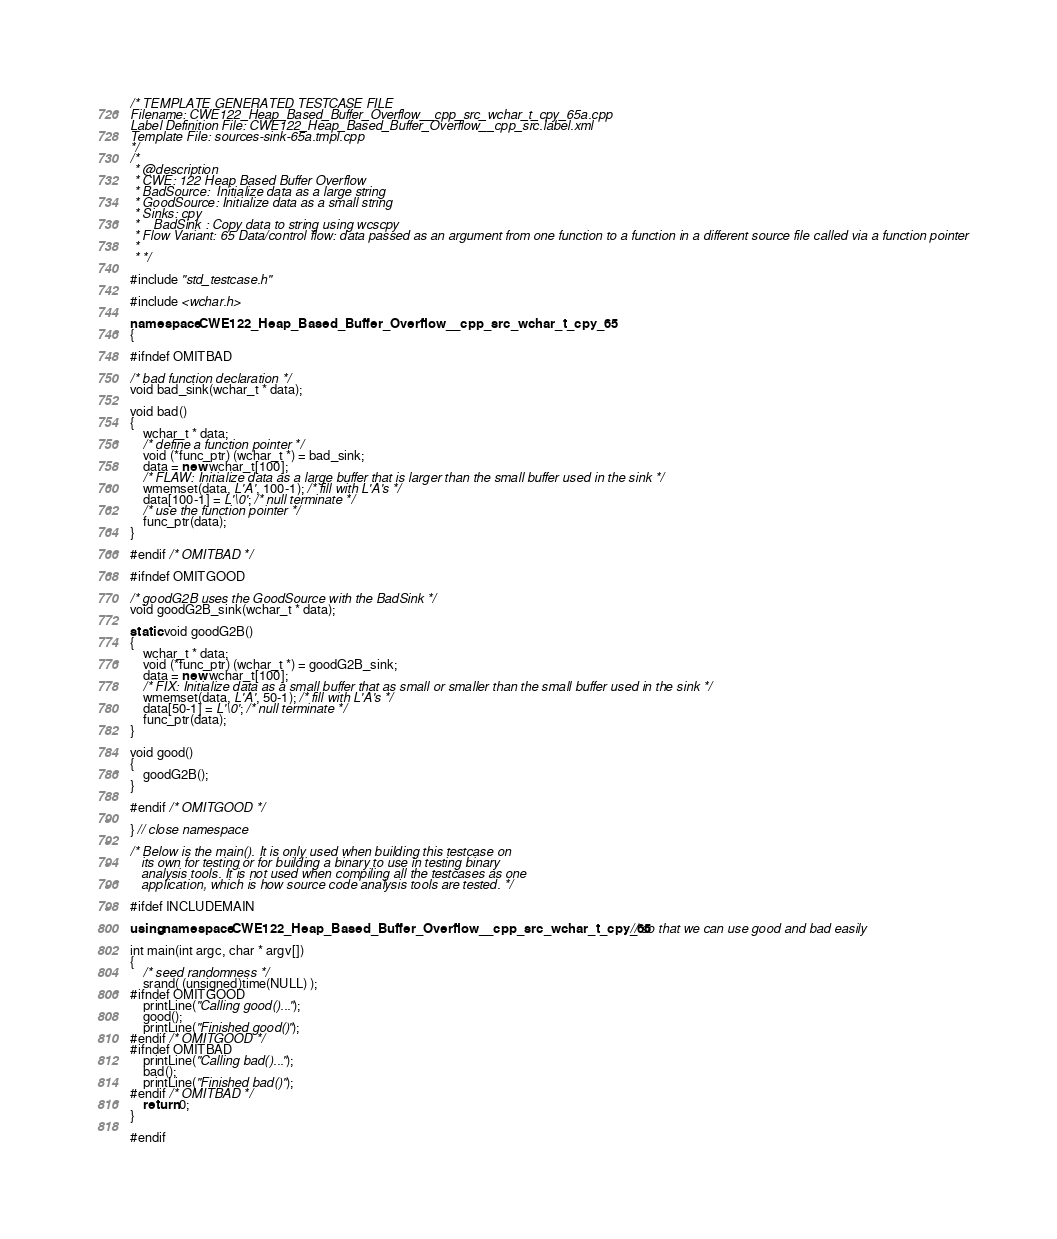Convert code to text. <code><loc_0><loc_0><loc_500><loc_500><_C++_>/* TEMPLATE GENERATED TESTCASE FILE
Filename: CWE122_Heap_Based_Buffer_Overflow__cpp_src_wchar_t_cpy_65a.cpp
Label Definition File: CWE122_Heap_Based_Buffer_Overflow__cpp_src.label.xml
Template File: sources-sink-65a.tmpl.cpp
*/
/*
 * @description
 * CWE: 122 Heap Based Buffer Overflow
 * BadSource:  Initialize data as a large string
 * GoodSource: Initialize data as a small string
 * Sinks: cpy
 *    BadSink : Copy data to string using wcscpy
 * Flow Variant: 65 Data/control flow: data passed as an argument from one function to a function in a different source file called via a function pointer
 *
 * */

#include "std_testcase.h"

#include <wchar.h>

namespace CWE122_Heap_Based_Buffer_Overflow__cpp_src_wchar_t_cpy_65
{

#ifndef OMITBAD

/* bad function declaration */
void bad_sink(wchar_t * data);

void bad()
{
    wchar_t * data;
    /* define a function pointer */
    void (*func_ptr) (wchar_t *) = bad_sink;
    data = new wchar_t[100];
    /* FLAW: Initialize data as a large buffer that is larger than the small buffer used in the sink */
    wmemset(data, L'A', 100-1); /* fill with L'A's */
    data[100-1] = L'\0'; /* null terminate */
    /* use the function pointer */
    func_ptr(data);
}

#endif /* OMITBAD */

#ifndef OMITGOOD

/* goodG2B uses the GoodSource with the BadSink */
void goodG2B_sink(wchar_t * data);

static void goodG2B()
{
    wchar_t * data;
    void (*func_ptr) (wchar_t *) = goodG2B_sink;
    data = new wchar_t[100];
    /* FIX: Initialize data as a small buffer that as small or smaller than the small buffer used in the sink */
    wmemset(data, L'A', 50-1); /* fill with L'A's */
    data[50-1] = L'\0'; /* null terminate */
    func_ptr(data);
}

void good()
{
    goodG2B();
}

#endif /* OMITGOOD */

} // close namespace

/* Below is the main(). It is only used when building this testcase on
   its own for testing or for building a binary to use in testing binary
   analysis tools. It is not used when compiling all the testcases as one
   application, which is how source code analysis tools are tested. */

#ifdef INCLUDEMAIN

using namespace CWE122_Heap_Based_Buffer_Overflow__cpp_src_wchar_t_cpy_65; // so that we can use good and bad easily

int main(int argc, char * argv[])
{
    /* seed randomness */
    srand( (unsigned)time(NULL) );
#ifndef OMITGOOD
    printLine("Calling good()...");
    good();
    printLine("Finished good()");
#endif /* OMITGOOD */
#ifndef OMITBAD
    printLine("Calling bad()...");
    bad();
    printLine("Finished bad()");
#endif /* OMITBAD */
    return 0;
}

#endif
</code> 